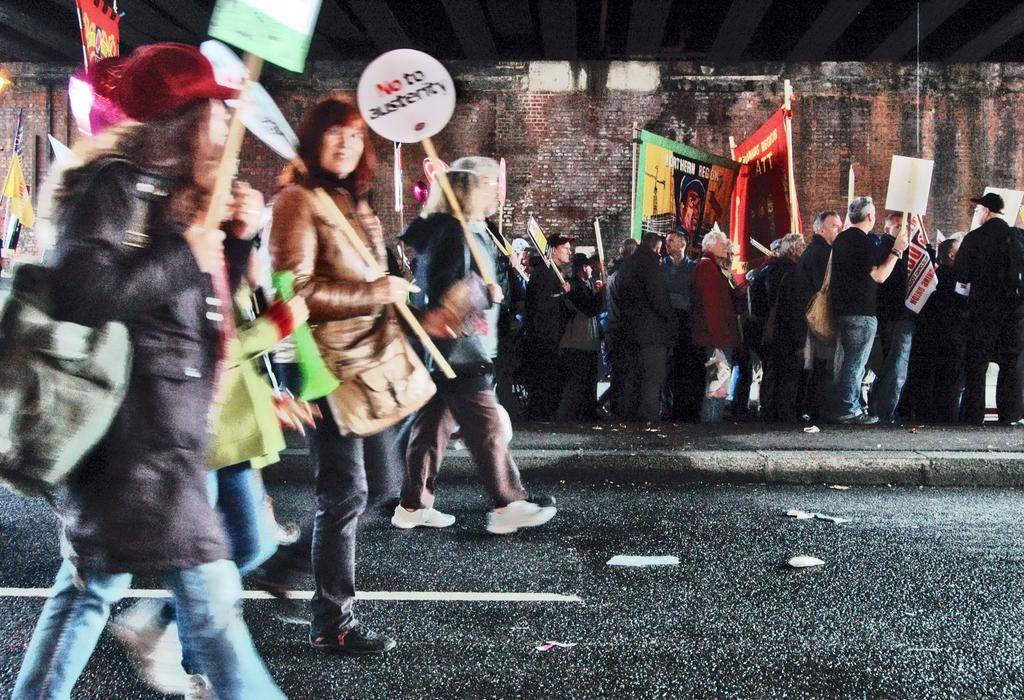What types of people are present in the image? There are men and women in the image. What are the men and women doing in the image? The men and women are protesting on the road. What can be seen in the background of the image? There is a brick wall in the background of the image. What type of pickle is being used as a prop during the protest in the image? There is no pickle present in the image; the men and women are protesting without any pickles. How many hens are visible in the image? There are no hens present in the image; the focus is on the men and women protesting. 